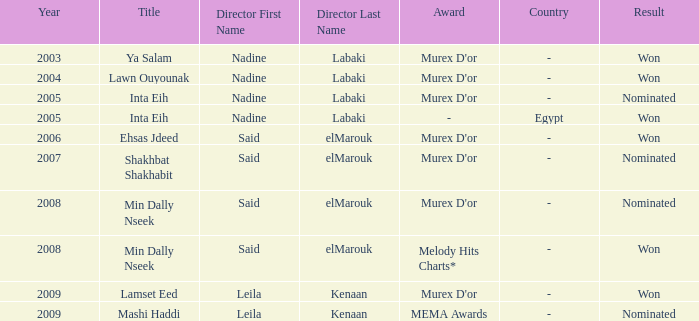What survey has the Ehsas Jdeed title? Murex D'or. 